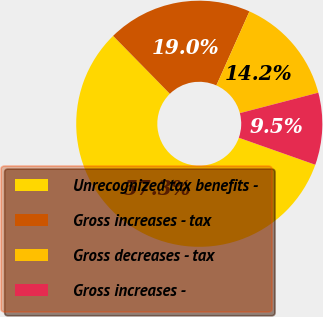Convert chart. <chart><loc_0><loc_0><loc_500><loc_500><pie_chart><fcel>Unrecognized tax benefits -<fcel>Gross increases - tax<fcel>Gross decreases - tax<fcel>Gross increases -<nl><fcel>57.26%<fcel>19.03%<fcel>14.25%<fcel>9.47%<nl></chart> 